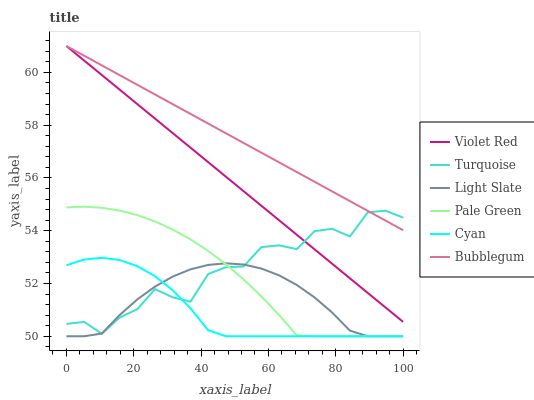Does Cyan have the minimum area under the curve?
Answer yes or no. Yes. Does Bubblegum have the maximum area under the curve?
Answer yes or no. Yes. Does Light Slate have the minimum area under the curve?
Answer yes or no. No. Does Light Slate have the maximum area under the curve?
Answer yes or no. No. Is Bubblegum the smoothest?
Answer yes or no. Yes. Is Turquoise the roughest?
Answer yes or no. Yes. Is Light Slate the smoothest?
Answer yes or no. No. Is Light Slate the roughest?
Answer yes or no. No. Does Turquoise have the lowest value?
Answer yes or no. No. Does Turquoise have the highest value?
Answer yes or no. No. Is Cyan less than Bubblegum?
Answer yes or no. Yes. Is Bubblegum greater than Light Slate?
Answer yes or no. Yes. Does Cyan intersect Bubblegum?
Answer yes or no. No. 